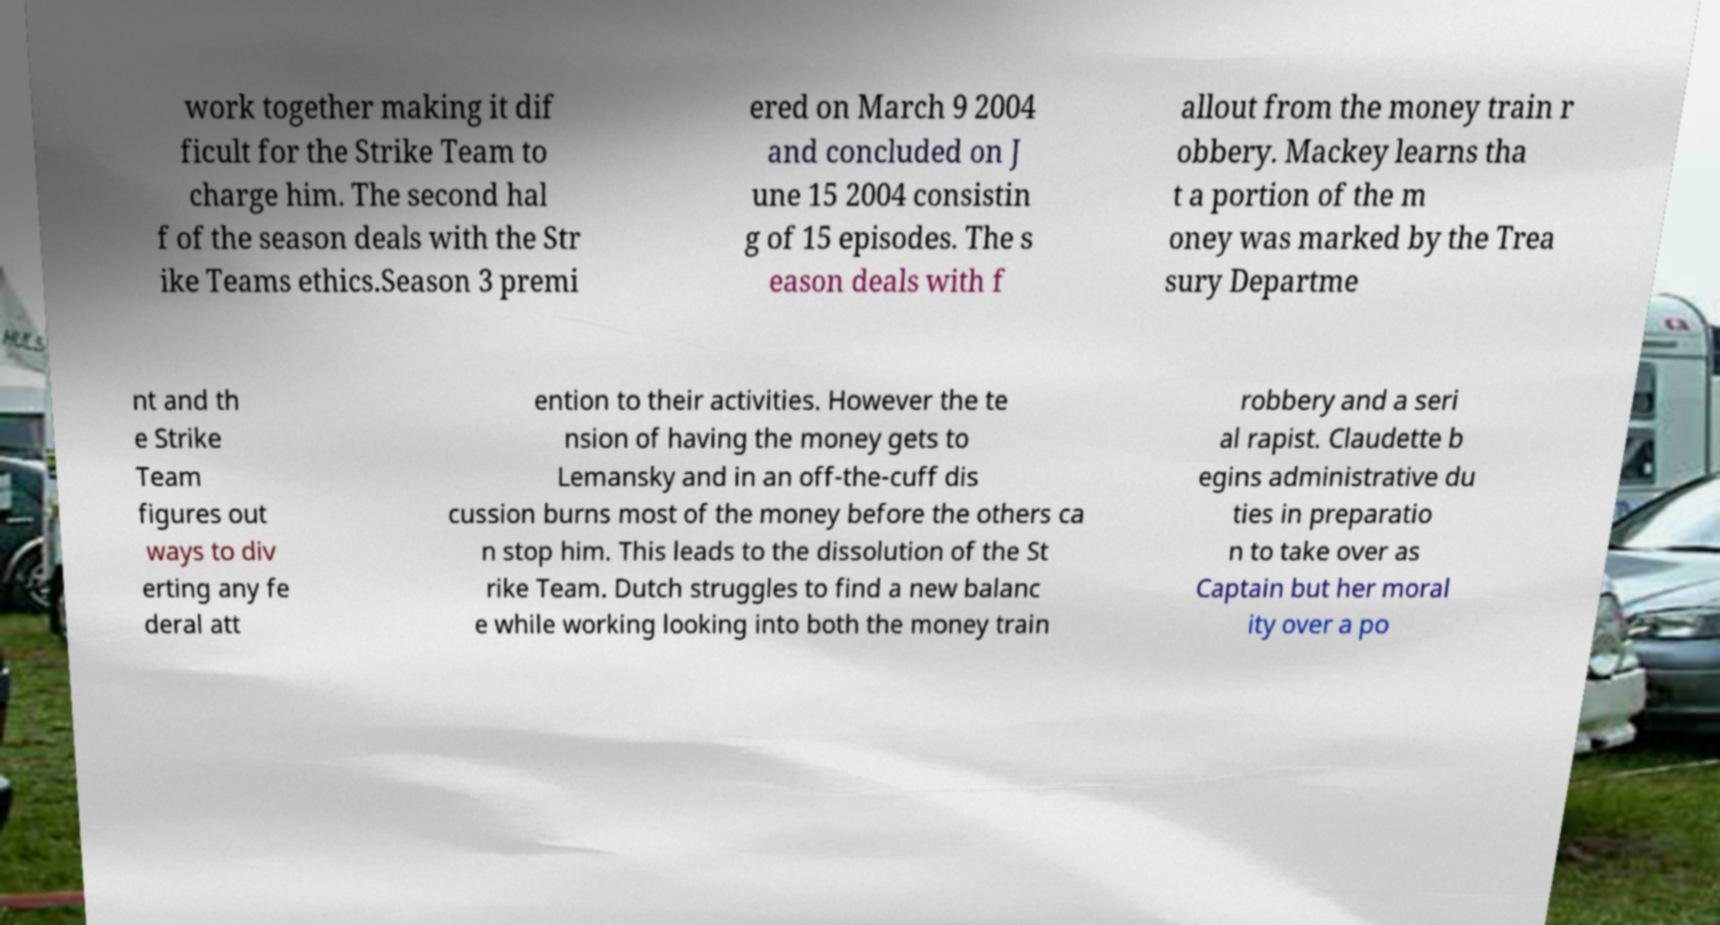Can you read and provide the text displayed in the image?This photo seems to have some interesting text. Can you extract and type it out for me? work together making it dif ficult for the Strike Team to charge him. The second hal f of the season deals with the Str ike Teams ethics.Season 3 premi ered on March 9 2004 and concluded on J une 15 2004 consistin g of 15 episodes. The s eason deals with f allout from the money train r obbery. Mackey learns tha t a portion of the m oney was marked by the Trea sury Departme nt and th e Strike Team figures out ways to div erting any fe deral att ention to their activities. However the te nsion of having the money gets to Lemansky and in an off-the-cuff dis cussion burns most of the money before the others ca n stop him. This leads to the dissolution of the St rike Team. Dutch struggles to find a new balanc e while working looking into both the money train robbery and a seri al rapist. Claudette b egins administrative du ties in preparatio n to take over as Captain but her moral ity over a po 